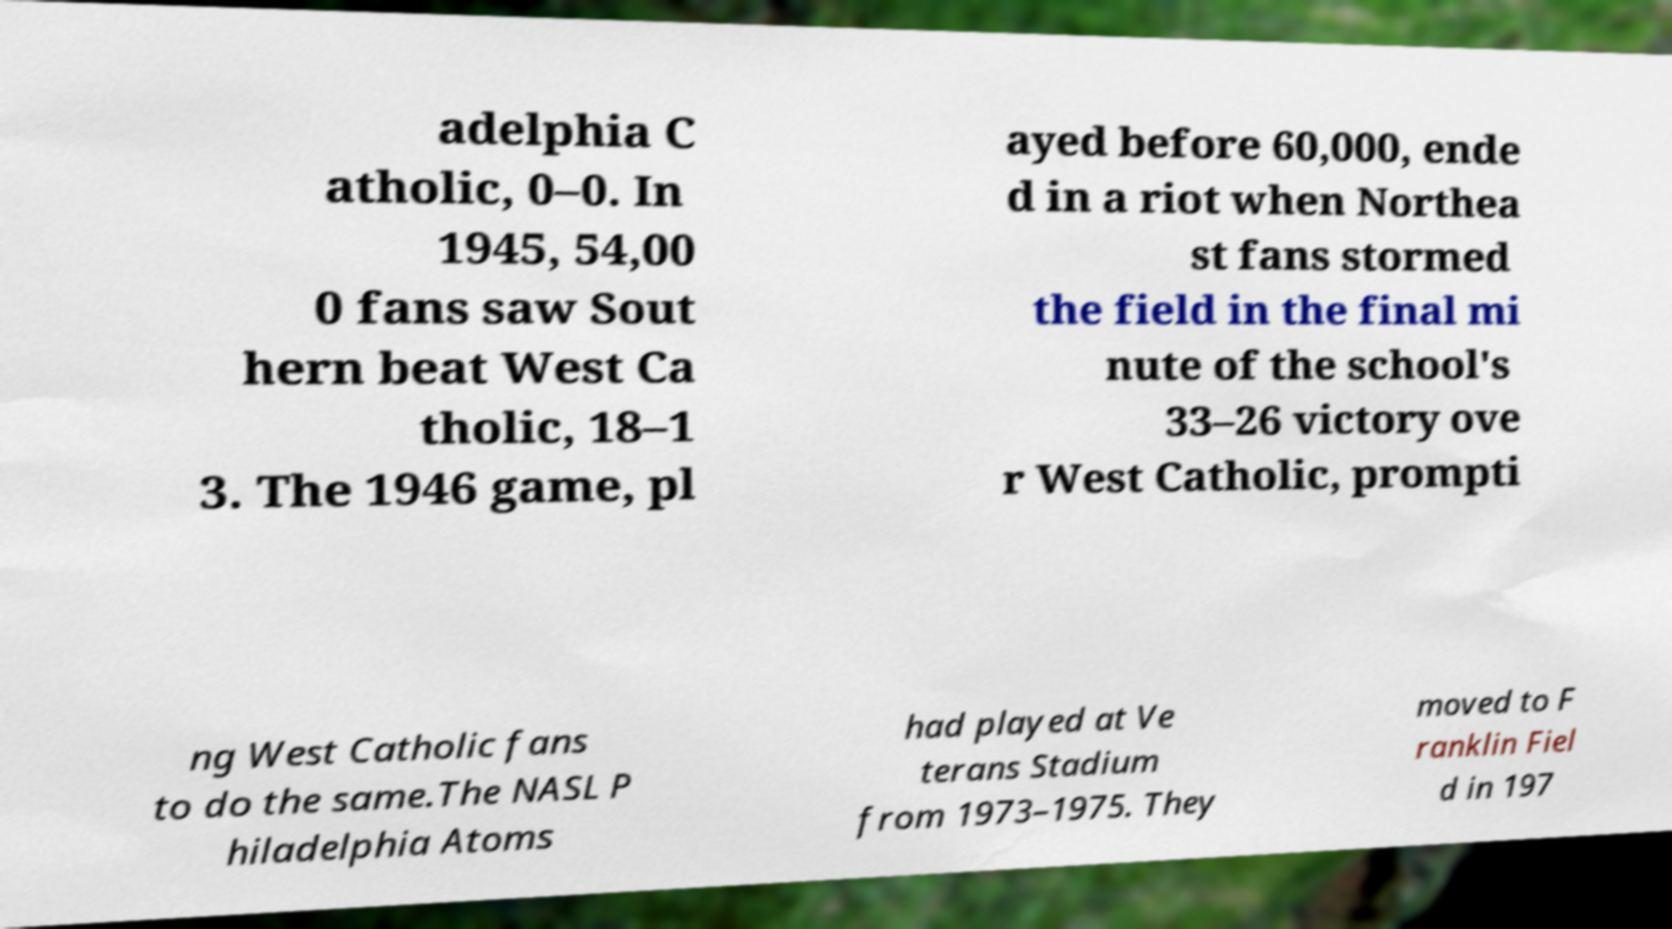What messages or text are displayed in this image? I need them in a readable, typed format. adelphia C atholic, 0–0. In 1945, 54,00 0 fans saw Sout hern beat West Ca tholic, 18–1 3. The 1946 game, pl ayed before 60,000, ende d in a riot when Northea st fans stormed the field in the final mi nute of the school's 33–26 victory ove r West Catholic, prompti ng West Catholic fans to do the same.The NASL P hiladelphia Atoms had played at Ve terans Stadium from 1973–1975. They moved to F ranklin Fiel d in 197 